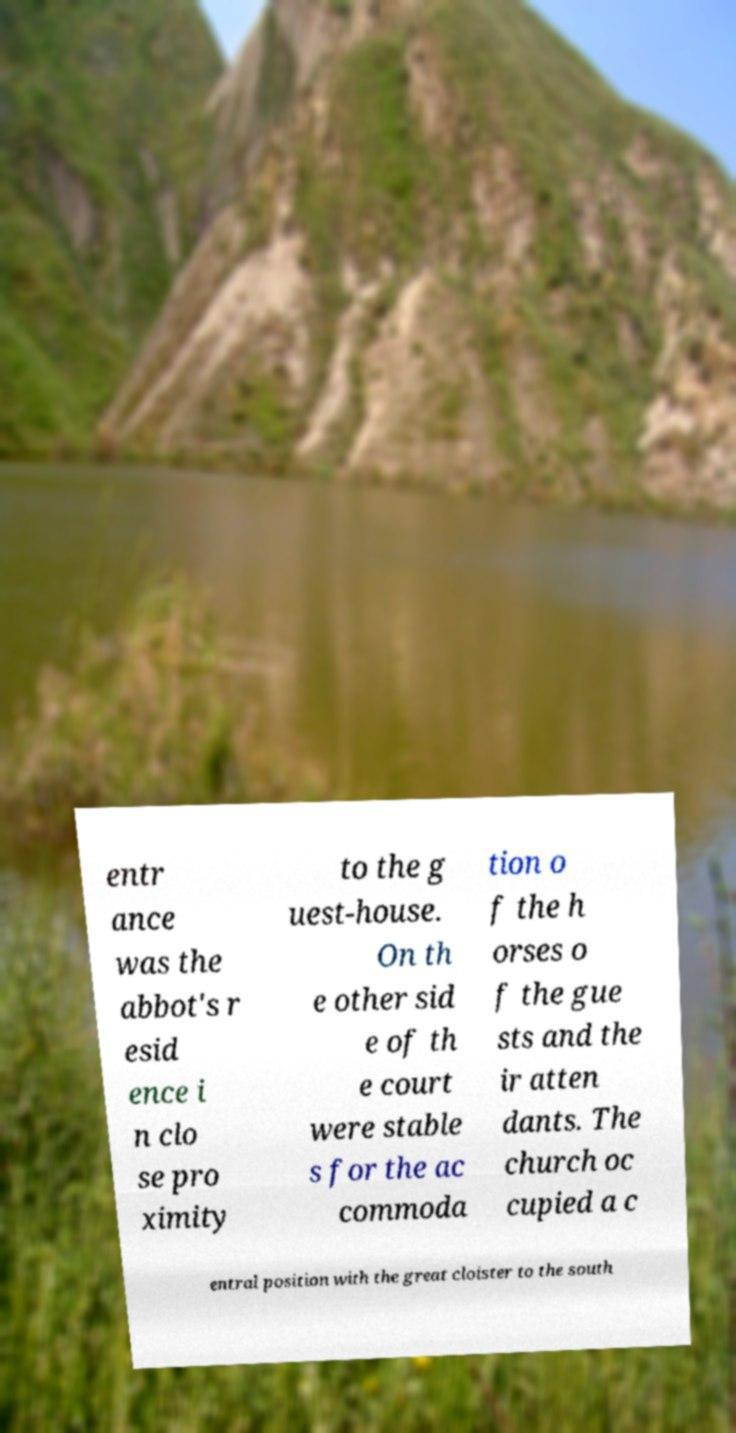For documentation purposes, I need the text within this image transcribed. Could you provide that? entr ance was the abbot's r esid ence i n clo se pro ximity to the g uest-house. On th e other sid e of th e court were stable s for the ac commoda tion o f the h orses o f the gue sts and the ir atten dants. The church oc cupied a c entral position with the great cloister to the south 